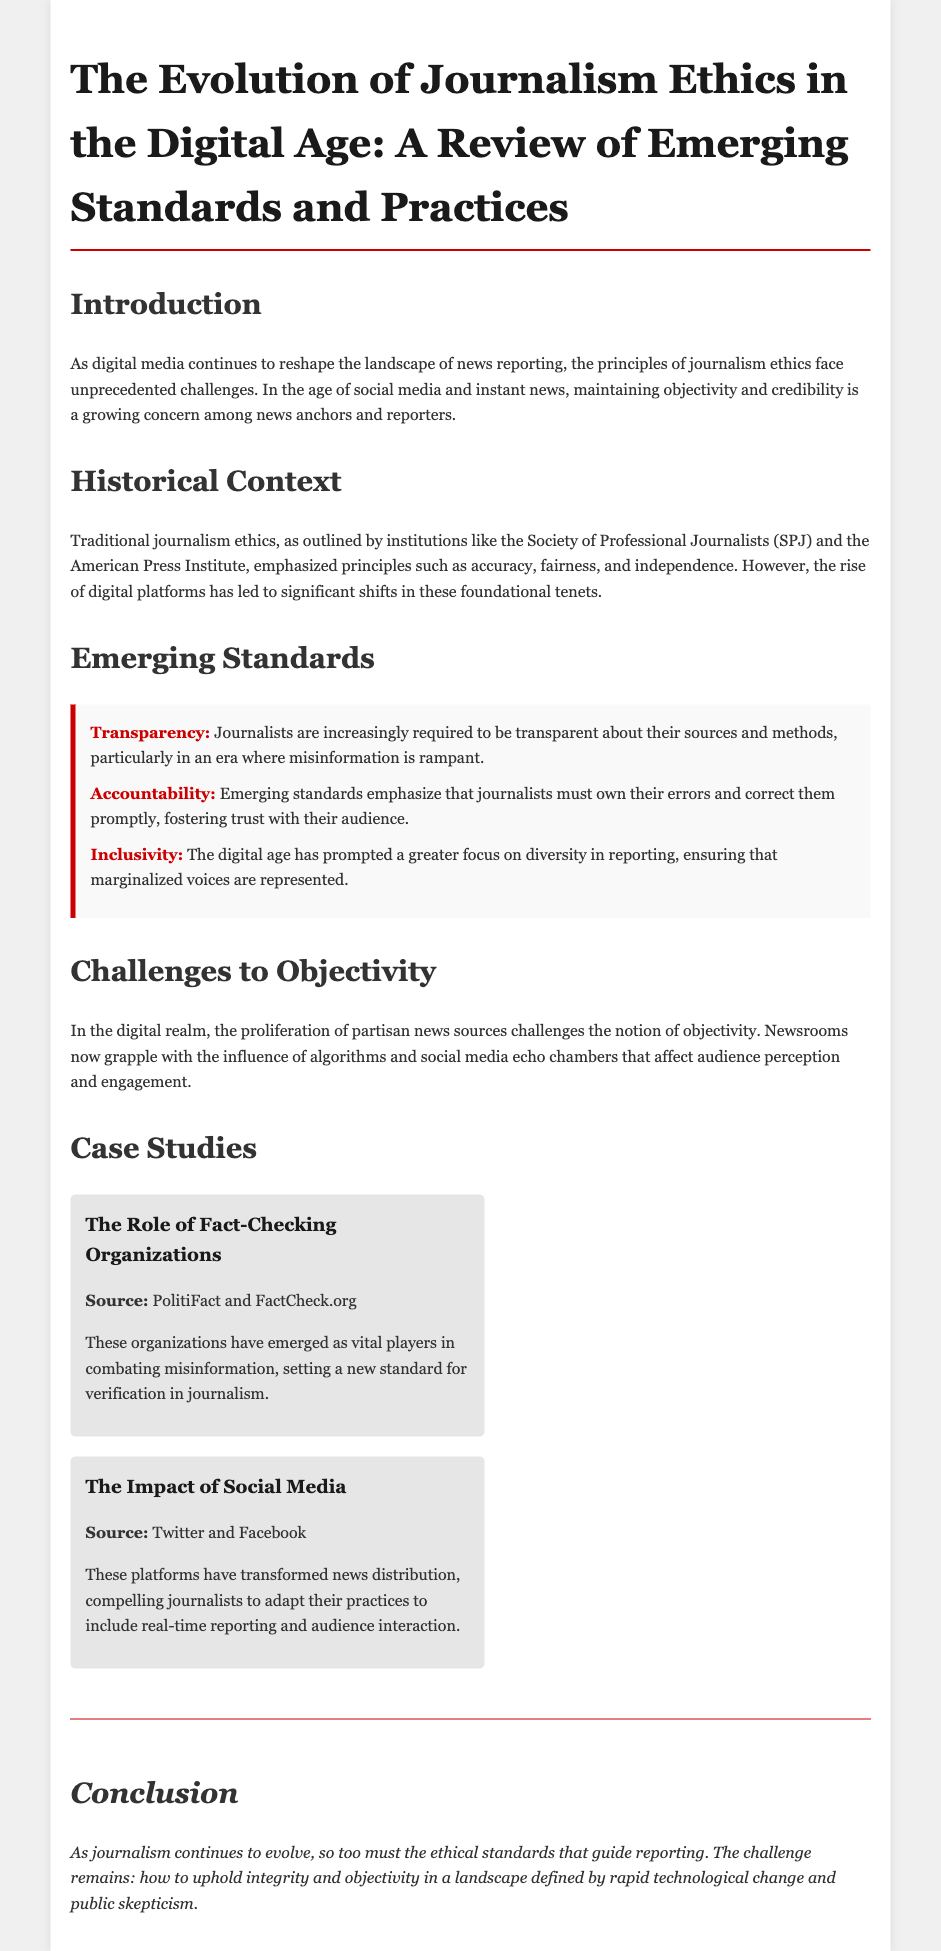What are the principles emphasized by traditional journalism ethics? Traditional journalism ethics emphasized principles such as accuracy, fairness, and independence.
Answer: accuracy, fairness, independence What emerging standard emphasizes the need for journalists to own their errors? The emerging standard that emphasizes this is Accountability.
Answer: Accountability Which organization is mentioned as a vital player in combating misinformation? PolitiFact and FactCheck.org are mentioned as vital players.
Answer: PolitiFact and FactCheck.org What challenge does the proliferation of partisan news sources create? The challenge created is to the notion of objectivity in journalism.
Answer: notion of objectivity What are the three emerging standards highlighted in the document? The three emerging standards are Transparency, Accountability, and Inclusivity.
Answer: Transparency, Accountability, Inclusivity What impact has social media had on journalism? Social media compels journalists to adapt their practices to include real-time reporting and audience interaction.
Answer: real-time reporting and audience interaction How does the document describe the influence of algorithms? The influence of algorithms affects audience perception and engagement.
Answer: audience perception and engagement What is the conclusion regarding the evolution of journalism ethics? The conclusion states that ethical standards must evolve to uphold integrity and objectivity.
Answer: uphold integrity and objectivity 